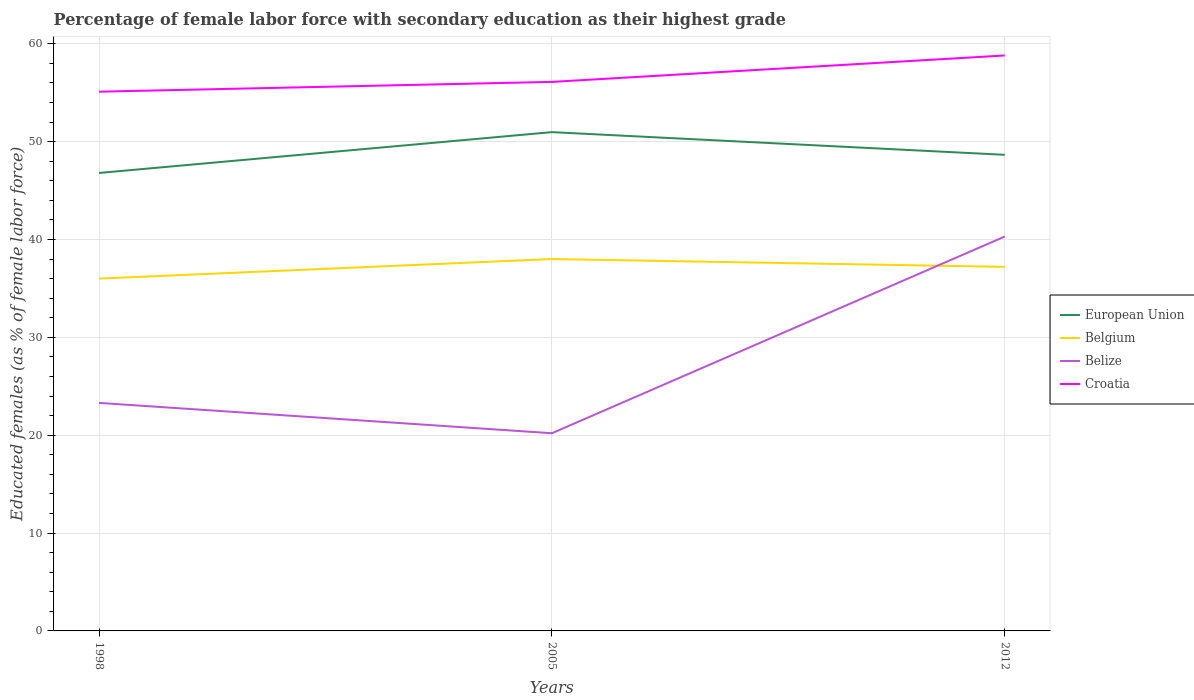Does the line corresponding to Belgium intersect with the line corresponding to Belize?
Offer a terse response. Yes. Across all years, what is the maximum percentage of female labor force with secondary education in Croatia?
Ensure brevity in your answer.  55.1. What is the total percentage of female labor force with secondary education in Croatia in the graph?
Offer a terse response. -3.7. What is the difference between the highest and the second highest percentage of female labor force with secondary education in Belize?
Your response must be concise. 20.1. How many lines are there?
Your answer should be very brief. 4. Does the graph contain any zero values?
Your answer should be compact. No. Does the graph contain grids?
Your response must be concise. Yes. What is the title of the graph?
Your response must be concise. Percentage of female labor force with secondary education as their highest grade. Does "Virgin Islands" appear as one of the legend labels in the graph?
Your answer should be very brief. No. What is the label or title of the Y-axis?
Your response must be concise. Educated females (as % of female labor force). What is the Educated females (as % of female labor force) in European Union in 1998?
Offer a very short reply. 46.79. What is the Educated females (as % of female labor force) of Belgium in 1998?
Your response must be concise. 36. What is the Educated females (as % of female labor force) of Belize in 1998?
Ensure brevity in your answer.  23.3. What is the Educated females (as % of female labor force) of Croatia in 1998?
Make the answer very short. 55.1. What is the Educated females (as % of female labor force) in European Union in 2005?
Make the answer very short. 50.97. What is the Educated females (as % of female labor force) in Belgium in 2005?
Make the answer very short. 38. What is the Educated females (as % of female labor force) in Belize in 2005?
Provide a succinct answer. 20.2. What is the Educated females (as % of female labor force) in Croatia in 2005?
Provide a succinct answer. 56.1. What is the Educated females (as % of female labor force) in European Union in 2012?
Keep it short and to the point. 48.65. What is the Educated females (as % of female labor force) in Belgium in 2012?
Offer a very short reply. 37.2. What is the Educated females (as % of female labor force) in Belize in 2012?
Your answer should be very brief. 40.3. What is the Educated females (as % of female labor force) of Croatia in 2012?
Keep it short and to the point. 58.8. Across all years, what is the maximum Educated females (as % of female labor force) of European Union?
Give a very brief answer. 50.97. Across all years, what is the maximum Educated females (as % of female labor force) in Belgium?
Provide a succinct answer. 38. Across all years, what is the maximum Educated females (as % of female labor force) of Belize?
Your answer should be compact. 40.3. Across all years, what is the maximum Educated females (as % of female labor force) in Croatia?
Give a very brief answer. 58.8. Across all years, what is the minimum Educated females (as % of female labor force) in European Union?
Your response must be concise. 46.79. Across all years, what is the minimum Educated females (as % of female labor force) of Belgium?
Provide a short and direct response. 36. Across all years, what is the minimum Educated females (as % of female labor force) in Belize?
Ensure brevity in your answer.  20.2. Across all years, what is the minimum Educated females (as % of female labor force) of Croatia?
Ensure brevity in your answer.  55.1. What is the total Educated females (as % of female labor force) in European Union in the graph?
Your answer should be very brief. 146.41. What is the total Educated females (as % of female labor force) of Belgium in the graph?
Your answer should be very brief. 111.2. What is the total Educated females (as % of female labor force) in Belize in the graph?
Give a very brief answer. 83.8. What is the total Educated females (as % of female labor force) in Croatia in the graph?
Your response must be concise. 170. What is the difference between the Educated females (as % of female labor force) of European Union in 1998 and that in 2005?
Your response must be concise. -4.17. What is the difference between the Educated females (as % of female labor force) of Belgium in 1998 and that in 2005?
Ensure brevity in your answer.  -2. What is the difference between the Educated females (as % of female labor force) in Belize in 1998 and that in 2005?
Provide a succinct answer. 3.1. What is the difference between the Educated females (as % of female labor force) of Croatia in 1998 and that in 2005?
Your answer should be very brief. -1. What is the difference between the Educated females (as % of female labor force) of European Union in 1998 and that in 2012?
Make the answer very short. -1.85. What is the difference between the Educated females (as % of female labor force) of European Union in 2005 and that in 2012?
Offer a terse response. 2.32. What is the difference between the Educated females (as % of female labor force) of Belgium in 2005 and that in 2012?
Your response must be concise. 0.8. What is the difference between the Educated females (as % of female labor force) in Belize in 2005 and that in 2012?
Ensure brevity in your answer.  -20.1. What is the difference between the Educated females (as % of female labor force) of Croatia in 2005 and that in 2012?
Offer a terse response. -2.7. What is the difference between the Educated females (as % of female labor force) in European Union in 1998 and the Educated females (as % of female labor force) in Belgium in 2005?
Ensure brevity in your answer.  8.79. What is the difference between the Educated females (as % of female labor force) of European Union in 1998 and the Educated females (as % of female labor force) of Belize in 2005?
Make the answer very short. 26.59. What is the difference between the Educated females (as % of female labor force) in European Union in 1998 and the Educated females (as % of female labor force) in Croatia in 2005?
Make the answer very short. -9.31. What is the difference between the Educated females (as % of female labor force) in Belgium in 1998 and the Educated females (as % of female labor force) in Croatia in 2005?
Your answer should be very brief. -20.1. What is the difference between the Educated females (as % of female labor force) of Belize in 1998 and the Educated females (as % of female labor force) of Croatia in 2005?
Offer a terse response. -32.8. What is the difference between the Educated females (as % of female labor force) of European Union in 1998 and the Educated females (as % of female labor force) of Belgium in 2012?
Ensure brevity in your answer.  9.59. What is the difference between the Educated females (as % of female labor force) of European Union in 1998 and the Educated females (as % of female labor force) of Belize in 2012?
Ensure brevity in your answer.  6.49. What is the difference between the Educated females (as % of female labor force) of European Union in 1998 and the Educated females (as % of female labor force) of Croatia in 2012?
Provide a short and direct response. -12.01. What is the difference between the Educated females (as % of female labor force) of Belgium in 1998 and the Educated females (as % of female labor force) of Belize in 2012?
Your answer should be very brief. -4.3. What is the difference between the Educated females (as % of female labor force) of Belgium in 1998 and the Educated females (as % of female labor force) of Croatia in 2012?
Your answer should be compact. -22.8. What is the difference between the Educated females (as % of female labor force) of Belize in 1998 and the Educated females (as % of female labor force) of Croatia in 2012?
Offer a very short reply. -35.5. What is the difference between the Educated females (as % of female labor force) of European Union in 2005 and the Educated females (as % of female labor force) of Belgium in 2012?
Your answer should be very brief. 13.77. What is the difference between the Educated females (as % of female labor force) in European Union in 2005 and the Educated females (as % of female labor force) in Belize in 2012?
Give a very brief answer. 10.67. What is the difference between the Educated females (as % of female labor force) of European Union in 2005 and the Educated females (as % of female labor force) of Croatia in 2012?
Your response must be concise. -7.83. What is the difference between the Educated females (as % of female labor force) of Belgium in 2005 and the Educated females (as % of female labor force) of Belize in 2012?
Provide a short and direct response. -2.3. What is the difference between the Educated females (as % of female labor force) in Belgium in 2005 and the Educated females (as % of female labor force) in Croatia in 2012?
Offer a very short reply. -20.8. What is the difference between the Educated females (as % of female labor force) in Belize in 2005 and the Educated females (as % of female labor force) in Croatia in 2012?
Make the answer very short. -38.6. What is the average Educated females (as % of female labor force) of European Union per year?
Keep it short and to the point. 48.8. What is the average Educated females (as % of female labor force) of Belgium per year?
Your response must be concise. 37.07. What is the average Educated females (as % of female labor force) in Belize per year?
Your response must be concise. 27.93. What is the average Educated females (as % of female labor force) in Croatia per year?
Offer a very short reply. 56.67. In the year 1998, what is the difference between the Educated females (as % of female labor force) in European Union and Educated females (as % of female labor force) in Belgium?
Your answer should be compact. 10.79. In the year 1998, what is the difference between the Educated females (as % of female labor force) of European Union and Educated females (as % of female labor force) of Belize?
Your answer should be compact. 23.49. In the year 1998, what is the difference between the Educated females (as % of female labor force) of European Union and Educated females (as % of female labor force) of Croatia?
Offer a terse response. -8.31. In the year 1998, what is the difference between the Educated females (as % of female labor force) in Belgium and Educated females (as % of female labor force) in Croatia?
Give a very brief answer. -19.1. In the year 1998, what is the difference between the Educated females (as % of female labor force) of Belize and Educated females (as % of female labor force) of Croatia?
Your answer should be compact. -31.8. In the year 2005, what is the difference between the Educated females (as % of female labor force) of European Union and Educated females (as % of female labor force) of Belgium?
Provide a short and direct response. 12.97. In the year 2005, what is the difference between the Educated females (as % of female labor force) in European Union and Educated females (as % of female labor force) in Belize?
Your response must be concise. 30.77. In the year 2005, what is the difference between the Educated females (as % of female labor force) of European Union and Educated females (as % of female labor force) of Croatia?
Provide a short and direct response. -5.13. In the year 2005, what is the difference between the Educated females (as % of female labor force) of Belgium and Educated females (as % of female labor force) of Belize?
Provide a succinct answer. 17.8. In the year 2005, what is the difference between the Educated females (as % of female labor force) in Belgium and Educated females (as % of female labor force) in Croatia?
Your response must be concise. -18.1. In the year 2005, what is the difference between the Educated females (as % of female labor force) in Belize and Educated females (as % of female labor force) in Croatia?
Your answer should be compact. -35.9. In the year 2012, what is the difference between the Educated females (as % of female labor force) in European Union and Educated females (as % of female labor force) in Belgium?
Provide a succinct answer. 11.45. In the year 2012, what is the difference between the Educated females (as % of female labor force) in European Union and Educated females (as % of female labor force) in Belize?
Provide a short and direct response. 8.35. In the year 2012, what is the difference between the Educated females (as % of female labor force) of European Union and Educated females (as % of female labor force) of Croatia?
Your answer should be compact. -10.15. In the year 2012, what is the difference between the Educated females (as % of female labor force) in Belgium and Educated females (as % of female labor force) in Belize?
Keep it short and to the point. -3.1. In the year 2012, what is the difference between the Educated females (as % of female labor force) in Belgium and Educated females (as % of female labor force) in Croatia?
Your response must be concise. -21.6. In the year 2012, what is the difference between the Educated females (as % of female labor force) in Belize and Educated females (as % of female labor force) in Croatia?
Your answer should be compact. -18.5. What is the ratio of the Educated females (as % of female labor force) in European Union in 1998 to that in 2005?
Offer a very short reply. 0.92. What is the ratio of the Educated females (as % of female labor force) of Belize in 1998 to that in 2005?
Your answer should be very brief. 1.15. What is the ratio of the Educated females (as % of female labor force) in Croatia in 1998 to that in 2005?
Offer a terse response. 0.98. What is the ratio of the Educated females (as % of female labor force) in European Union in 1998 to that in 2012?
Offer a very short reply. 0.96. What is the ratio of the Educated females (as % of female labor force) in Belgium in 1998 to that in 2012?
Your response must be concise. 0.97. What is the ratio of the Educated females (as % of female labor force) in Belize in 1998 to that in 2012?
Give a very brief answer. 0.58. What is the ratio of the Educated females (as % of female labor force) of Croatia in 1998 to that in 2012?
Give a very brief answer. 0.94. What is the ratio of the Educated females (as % of female labor force) in European Union in 2005 to that in 2012?
Offer a very short reply. 1.05. What is the ratio of the Educated females (as % of female labor force) of Belgium in 2005 to that in 2012?
Keep it short and to the point. 1.02. What is the ratio of the Educated females (as % of female labor force) in Belize in 2005 to that in 2012?
Provide a short and direct response. 0.5. What is the ratio of the Educated females (as % of female labor force) in Croatia in 2005 to that in 2012?
Your response must be concise. 0.95. What is the difference between the highest and the second highest Educated females (as % of female labor force) in European Union?
Provide a succinct answer. 2.32. What is the difference between the highest and the second highest Educated females (as % of female labor force) in Croatia?
Keep it short and to the point. 2.7. What is the difference between the highest and the lowest Educated females (as % of female labor force) of European Union?
Offer a very short reply. 4.17. What is the difference between the highest and the lowest Educated females (as % of female labor force) of Belgium?
Offer a very short reply. 2. What is the difference between the highest and the lowest Educated females (as % of female labor force) of Belize?
Your answer should be very brief. 20.1. 